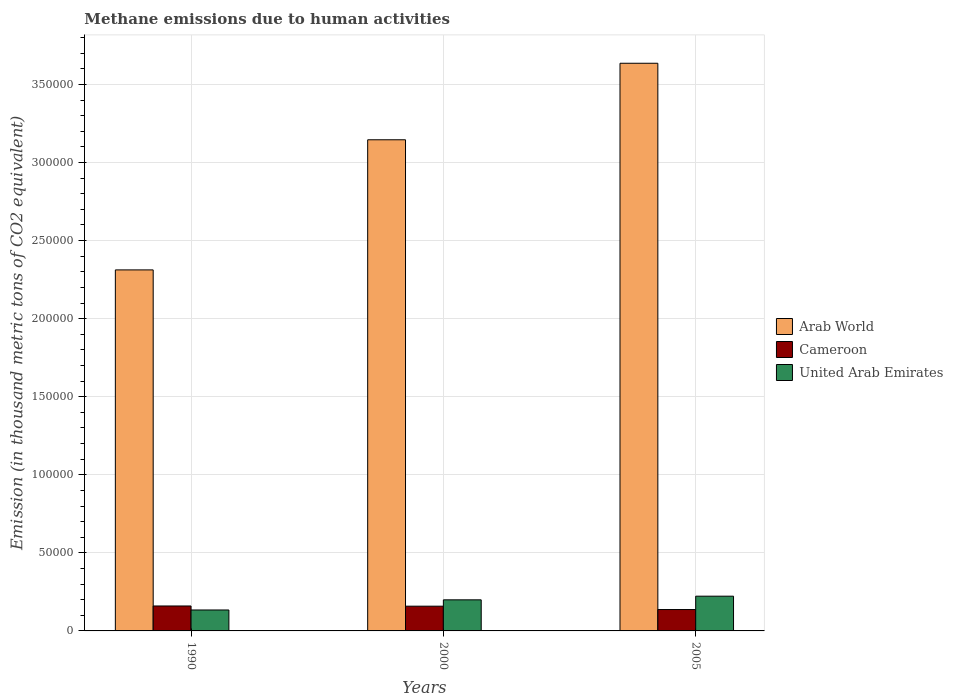Are the number of bars per tick equal to the number of legend labels?
Give a very brief answer. Yes. Are the number of bars on each tick of the X-axis equal?
Your answer should be very brief. Yes. What is the label of the 2nd group of bars from the left?
Make the answer very short. 2000. In how many cases, is the number of bars for a given year not equal to the number of legend labels?
Your response must be concise. 0. What is the amount of methane emitted in Arab World in 1990?
Offer a very short reply. 2.31e+05. Across all years, what is the maximum amount of methane emitted in Cameroon?
Provide a succinct answer. 1.60e+04. Across all years, what is the minimum amount of methane emitted in Cameroon?
Give a very brief answer. 1.37e+04. What is the total amount of methane emitted in United Arab Emirates in the graph?
Offer a very short reply. 5.56e+04. What is the difference between the amount of methane emitted in Cameroon in 2000 and that in 2005?
Your answer should be compact. 2143.3. What is the difference between the amount of methane emitted in United Arab Emirates in 2000 and the amount of methane emitted in Arab World in 1990?
Ensure brevity in your answer.  -2.11e+05. What is the average amount of methane emitted in Arab World per year?
Your answer should be compact. 3.03e+05. In the year 2005, what is the difference between the amount of methane emitted in Cameroon and amount of methane emitted in United Arab Emirates?
Ensure brevity in your answer.  -8556. In how many years, is the amount of methane emitted in Arab World greater than 90000 thousand metric tons?
Offer a terse response. 3. What is the ratio of the amount of methane emitted in Arab World in 1990 to that in 2000?
Your response must be concise. 0.74. Is the difference between the amount of methane emitted in Cameroon in 1990 and 2000 greater than the difference between the amount of methane emitted in United Arab Emirates in 1990 and 2000?
Provide a succinct answer. Yes. What is the difference between the highest and the second highest amount of methane emitted in Cameroon?
Ensure brevity in your answer.  137.2. What is the difference between the highest and the lowest amount of methane emitted in Arab World?
Your answer should be compact. 1.32e+05. Is the sum of the amount of methane emitted in Cameroon in 1990 and 2005 greater than the maximum amount of methane emitted in United Arab Emirates across all years?
Your answer should be compact. Yes. What does the 3rd bar from the left in 2005 represents?
Ensure brevity in your answer.  United Arab Emirates. What does the 1st bar from the right in 2000 represents?
Your answer should be compact. United Arab Emirates. Is it the case that in every year, the sum of the amount of methane emitted in Arab World and amount of methane emitted in United Arab Emirates is greater than the amount of methane emitted in Cameroon?
Provide a short and direct response. Yes. Are all the bars in the graph horizontal?
Ensure brevity in your answer.  No. Are the values on the major ticks of Y-axis written in scientific E-notation?
Ensure brevity in your answer.  No. Does the graph contain grids?
Keep it short and to the point. Yes. Where does the legend appear in the graph?
Give a very brief answer. Center right. How many legend labels are there?
Your answer should be compact. 3. What is the title of the graph?
Make the answer very short. Methane emissions due to human activities. What is the label or title of the Y-axis?
Offer a terse response. Emission (in thousand metric tons of CO2 equivalent). What is the Emission (in thousand metric tons of CO2 equivalent) of Arab World in 1990?
Offer a terse response. 2.31e+05. What is the Emission (in thousand metric tons of CO2 equivalent) of Cameroon in 1990?
Offer a very short reply. 1.60e+04. What is the Emission (in thousand metric tons of CO2 equivalent) in United Arab Emirates in 1990?
Your answer should be compact. 1.34e+04. What is the Emission (in thousand metric tons of CO2 equivalent) in Arab World in 2000?
Your response must be concise. 3.15e+05. What is the Emission (in thousand metric tons of CO2 equivalent) in Cameroon in 2000?
Offer a terse response. 1.58e+04. What is the Emission (in thousand metric tons of CO2 equivalent) in United Arab Emirates in 2000?
Your answer should be very brief. 1.99e+04. What is the Emission (in thousand metric tons of CO2 equivalent) of Arab World in 2005?
Make the answer very short. 3.64e+05. What is the Emission (in thousand metric tons of CO2 equivalent) of Cameroon in 2005?
Your answer should be compact. 1.37e+04. What is the Emission (in thousand metric tons of CO2 equivalent) of United Arab Emirates in 2005?
Provide a short and direct response. 2.23e+04. Across all years, what is the maximum Emission (in thousand metric tons of CO2 equivalent) of Arab World?
Make the answer very short. 3.64e+05. Across all years, what is the maximum Emission (in thousand metric tons of CO2 equivalent) of Cameroon?
Ensure brevity in your answer.  1.60e+04. Across all years, what is the maximum Emission (in thousand metric tons of CO2 equivalent) in United Arab Emirates?
Keep it short and to the point. 2.23e+04. Across all years, what is the minimum Emission (in thousand metric tons of CO2 equivalent) in Arab World?
Your answer should be compact. 2.31e+05. Across all years, what is the minimum Emission (in thousand metric tons of CO2 equivalent) in Cameroon?
Keep it short and to the point. 1.37e+04. Across all years, what is the minimum Emission (in thousand metric tons of CO2 equivalent) of United Arab Emirates?
Ensure brevity in your answer.  1.34e+04. What is the total Emission (in thousand metric tons of CO2 equivalent) of Arab World in the graph?
Provide a short and direct response. 9.09e+05. What is the total Emission (in thousand metric tons of CO2 equivalent) of Cameroon in the graph?
Ensure brevity in your answer.  4.55e+04. What is the total Emission (in thousand metric tons of CO2 equivalent) in United Arab Emirates in the graph?
Provide a succinct answer. 5.56e+04. What is the difference between the Emission (in thousand metric tons of CO2 equivalent) in Arab World in 1990 and that in 2000?
Your response must be concise. -8.33e+04. What is the difference between the Emission (in thousand metric tons of CO2 equivalent) in Cameroon in 1990 and that in 2000?
Provide a short and direct response. 137.2. What is the difference between the Emission (in thousand metric tons of CO2 equivalent) in United Arab Emirates in 1990 and that in 2000?
Your answer should be compact. -6499. What is the difference between the Emission (in thousand metric tons of CO2 equivalent) in Arab World in 1990 and that in 2005?
Provide a succinct answer. -1.32e+05. What is the difference between the Emission (in thousand metric tons of CO2 equivalent) of Cameroon in 1990 and that in 2005?
Provide a succinct answer. 2280.5. What is the difference between the Emission (in thousand metric tons of CO2 equivalent) of United Arab Emirates in 1990 and that in 2005?
Keep it short and to the point. -8841.4. What is the difference between the Emission (in thousand metric tons of CO2 equivalent) of Arab World in 2000 and that in 2005?
Provide a short and direct response. -4.90e+04. What is the difference between the Emission (in thousand metric tons of CO2 equivalent) of Cameroon in 2000 and that in 2005?
Make the answer very short. 2143.3. What is the difference between the Emission (in thousand metric tons of CO2 equivalent) in United Arab Emirates in 2000 and that in 2005?
Ensure brevity in your answer.  -2342.4. What is the difference between the Emission (in thousand metric tons of CO2 equivalent) of Arab World in 1990 and the Emission (in thousand metric tons of CO2 equivalent) of Cameroon in 2000?
Your answer should be compact. 2.15e+05. What is the difference between the Emission (in thousand metric tons of CO2 equivalent) of Arab World in 1990 and the Emission (in thousand metric tons of CO2 equivalent) of United Arab Emirates in 2000?
Keep it short and to the point. 2.11e+05. What is the difference between the Emission (in thousand metric tons of CO2 equivalent) in Cameroon in 1990 and the Emission (in thousand metric tons of CO2 equivalent) in United Arab Emirates in 2000?
Provide a short and direct response. -3933.1. What is the difference between the Emission (in thousand metric tons of CO2 equivalent) in Arab World in 1990 and the Emission (in thousand metric tons of CO2 equivalent) in Cameroon in 2005?
Give a very brief answer. 2.18e+05. What is the difference between the Emission (in thousand metric tons of CO2 equivalent) in Arab World in 1990 and the Emission (in thousand metric tons of CO2 equivalent) in United Arab Emirates in 2005?
Your response must be concise. 2.09e+05. What is the difference between the Emission (in thousand metric tons of CO2 equivalent) of Cameroon in 1990 and the Emission (in thousand metric tons of CO2 equivalent) of United Arab Emirates in 2005?
Your response must be concise. -6275.5. What is the difference between the Emission (in thousand metric tons of CO2 equivalent) in Arab World in 2000 and the Emission (in thousand metric tons of CO2 equivalent) in Cameroon in 2005?
Offer a terse response. 3.01e+05. What is the difference between the Emission (in thousand metric tons of CO2 equivalent) in Arab World in 2000 and the Emission (in thousand metric tons of CO2 equivalent) in United Arab Emirates in 2005?
Provide a short and direct response. 2.92e+05. What is the difference between the Emission (in thousand metric tons of CO2 equivalent) in Cameroon in 2000 and the Emission (in thousand metric tons of CO2 equivalent) in United Arab Emirates in 2005?
Give a very brief answer. -6412.7. What is the average Emission (in thousand metric tons of CO2 equivalent) in Arab World per year?
Ensure brevity in your answer.  3.03e+05. What is the average Emission (in thousand metric tons of CO2 equivalent) in Cameroon per year?
Provide a succinct answer. 1.52e+04. What is the average Emission (in thousand metric tons of CO2 equivalent) in United Arab Emirates per year?
Offer a terse response. 1.85e+04. In the year 1990, what is the difference between the Emission (in thousand metric tons of CO2 equivalent) of Arab World and Emission (in thousand metric tons of CO2 equivalent) of Cameroon?
Make the answer very short. 2.15e+05. In the year 1990, what is the difference between the Emission (in thousand metric tons of CO2 equivalent) in Arab World and Emission (in thousand metric tons of CO2 equivalent) in United Arab Emirates?
Keep it short and to the point. 2.18e+05. In the year 1990, what is the difference between the Emission (in thousand metric tons of CO2 equivalent) in Cameroon and Emission (in thousand metric tons of CO2 equivalent) in United Arab Emirates?
Your answer should be compact. 2565.9. In the year 2000, what is the difference between the Emission (in thousand metric tons of CO2 equivalent) of Arab World and Emission (in thousand metric tons of CO2 equivalent) of Cameroon?
Provide a succinct answer. 2.99e+05. In the year 2000, what is the difference between the Emission (in thousand metric tons of CO2 equivalent) of Arab World and Emission (in thousand metric tons of CO2 equivalent) of United Arab Emirates?
Your response must be concise. 2.95e+05. In the year 2000, what is the difference between the Emission (in thousand metric tons of CO2 equivalent) in Cameroon and Emission (in thousand metric tons of CO2 equivalent) in United Arab Emirates?
Keep it short and to the point. -4070.3. In the year 2005, what is the difference between the Emission (in thousand metric tons of CO2 equivalent) of Arab World and Emission (in thousand metric tons of CO2 equivalent) of Cameroon?
Your answer should be compact. 3.50e+05. In the year 2005, what is the difference between the Emission (in thousand metric tons of CO2 equivalent) of Arab World and Emission (in thousand metric tons of CO2 equivalent) of United Arab Emirates?
Give a very brief answer. 3.41e+05. In the year 2005, what is the difference between the Emission (in thousand metric tons of CO2 equivalent) in Cameroon and Emission (in thousand metric tons of CO2 equivalent) in United Arab Emirates?
Give a very brief answer. -8556. What is the ratio of the Emission (in thousand metric tons of CO2 equivalent) in Arab World in 1990 to that in 2000?
Offer a terse response. 0.74. What is the ratio of the Emission (in thousand metric tons of CO2 equivalent) of Cameroon in 1990 to that in 2000?
Your answer should be very brief. 1.01. What is the ratio of the Emission (in thousand metric tons of CO2 equivalent) in United Arab Emirates in 1990 to that in 2000?
Keep it short and to the point. 0.67. What is the ratio of the Emission (in thousand metric tons of CO2 equivalent) in Arab World in 1990 to that in 2005?
Provide a succinct answer. 0.64. What is the ratio of the Emission (in thousand metric tons of CO2 equivalent) in Cameroon in 1990 to that in 2005?
Make the answer very short. 1.17. What is the ratio of the Emission (in thousand metric tons of CO2 equivalent) in United Arab Emirates in 1990 to that in 2005?
Make the answer very short. 0.6. What is the ratio of the Emission (in thousand metric tons of CO2 equivalent) of Arab World in 2000 to that in 2005?
Keep it short and to the point. 0.87. What is the ratio of the Emission (in thousand metric tons of CO2 equivalent) of Cameroon in 2000 to that in 2005?
Your answer should be compact. 1.16. What is the ratio of the Emission (in thousand metric tons of CO2 equivalent) of United Arab Emirates in 2000 to that in 2005?
Your answer should be compact. 0.89. What is the difference between the highest and the second highest Emission (in thousand metric tons of CO2 equivalent) of Arab World?
Your answer should be compact. 4.90e+04. What is the difference between the highest and the second highest Emission (in thousand metric tons of CO2 equivalent) in Cameroon?
Your response must be concise. 137.2. What is the difference between the highest and the second highest Emission (in thousand metric tons of CO2 equivalent) in United Arab Emirates?
Ensure brevity in your answer.  2342.4. What is the difference between the highest and the lowest Emission (in thousand metric tons of CO2 equivalent) in Arab World?
Offer a very short reply. 1.32e+05. What is the difference between the highest and the lowest Emission (in thousand metric tons of CO2 equivalent) in Cameroon?
Provide a succinct answer. 2280.5. What is the difference between the highest and the lowest Emission (in thousand metric tons of CO2 equivalent) of United Arab Emirates?
Keep it short and to the point. 8841.4. 